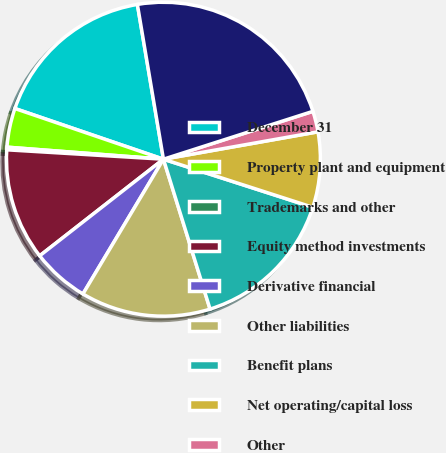Convert chart. <chart><loc_0><loc_0><loc_500><loc_500><pie_chart><fcel>December 31<fcel>Property plant and equipment<fcel>Trademarks and other<fcel>Equity method investments<fcel>Derivative financial<fcel>Other liabilities<fcel>Benefit plans<fcel>Net operating/capital loss<fcel>Other<fcel>Gross deferred tax assets<nl><fcel>17.11%<fcel>4.01%<fcel>0.27%<fcel>11.5%<fcel>5.88%<fcel>13.37%<fcel>15.24%<fcel>7.75%<fcel>2.14%<fcel>22.72%<nl></chart> 